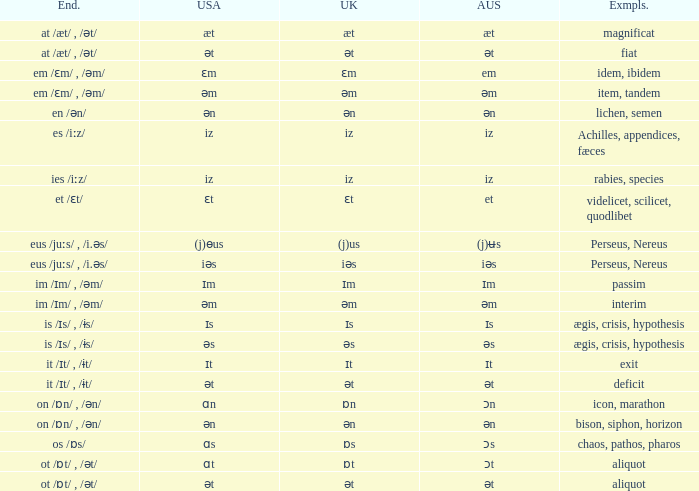Which Ending has British of iz, and Examples of achilles, appendices, fæces? Es /iːz/. 